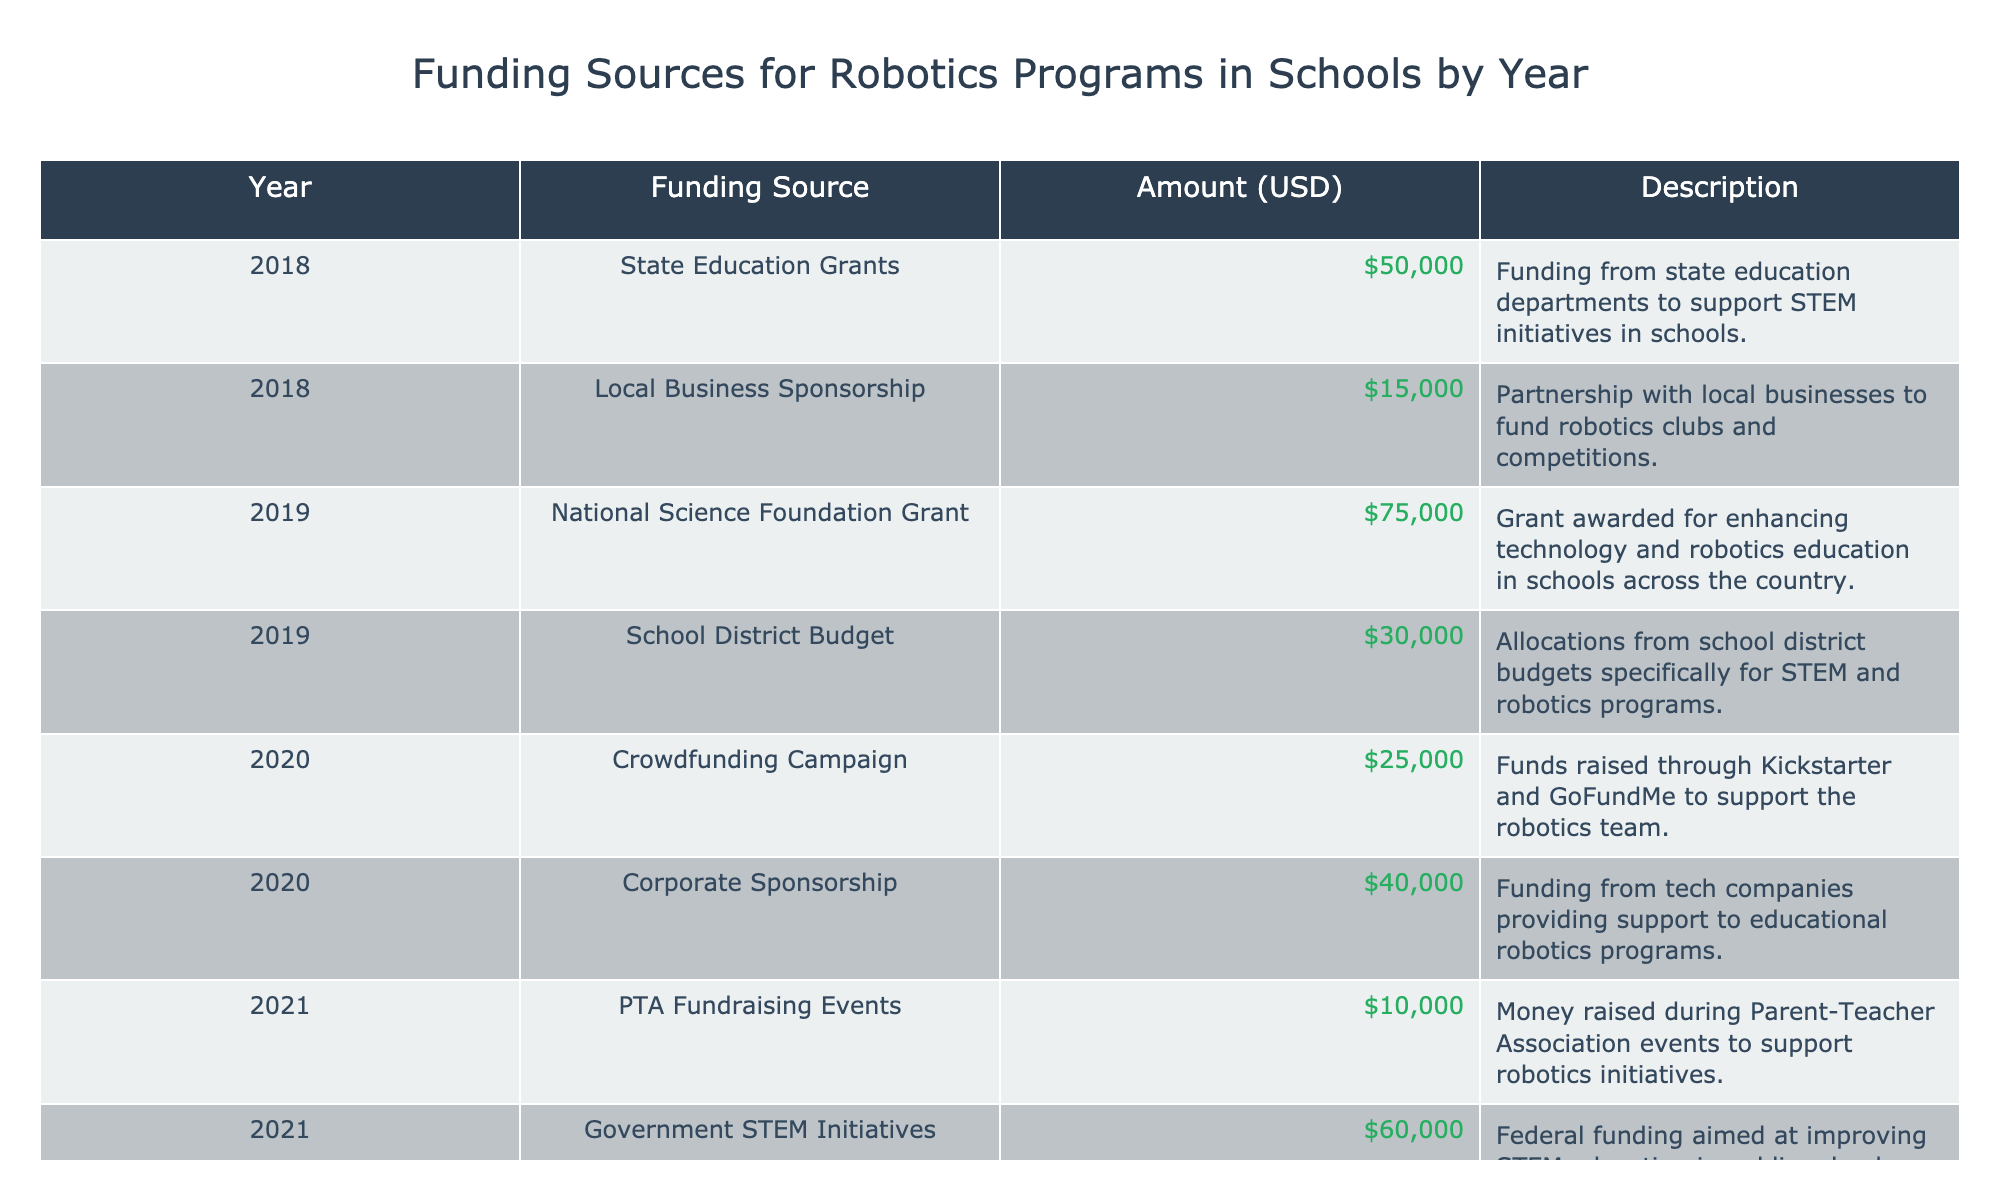What was the amount of funding from Local Business Sponsorship in 2018? Looking at the table, the amount listed for Local Business Sponsorship under the year 2018 is $15,000.
Answer: $15,000 What is the total amount of funding received from State Education Grants and Government STEM Initiatives combined? The amounts for State Education Grants and Government STEM Initiatives are $50,000 and $60,000, respectively. Adding these together gives $50,000 + $60,000 = $110,000.
Answer: $110,000 Did the funding from Corporate Sponsorship in 2020 exceed $30,000? The table shows that the Corporate Sponsorship amount for 2020 is $40,000, which is greater than $30,000. Thus, the statement is true.
Answer: Yes What year had the highest amount of funding from the Tech Industry Partnership? The table indicates that the Tech Industry Partnership provided funding in 2023 with an amount of $90,000, which is the highest amount listed for any funding source.
Answer: 2023 What was the average funding from Local Community Foundation and Robotics Competition Grants in 2022? The amounts for the Local Community Foundation and Robotics Competition Grants in 2022 are $12,000 and $20,000. To find the average, add these two amounts ($12,000 + $20,000 = $32,000) and divide by the number of entries (2). Thus, the average is $32,000 / 2 = $16,000.
Answer: $16,000 Was there an increase in funding from the School District Budget in 2019 compared to 2018? In the table, the School District Budget funding is shown only for 2019, which amounts to $30,000. There is no entry for 2018. Therefore, we cannot determine an increase based on the available data.
Answer: No How much total funding was provided for STEM initiatives from the PTA Fundraising Events and the Local Business Sponsorship in 2018? The PTA Fundraising Events in 2021 contributed $10,000, while the Local Business Sponsorship in 2018 contributed $15,000. The total funding is calculated as $10,000 + $15,000 = $25,000.
Answer: $25,000 Compare the total funding received in 2020 to that in 2021. Which year had more total funding? In 2020, the total funding was $25,000 (Crowdfunding Campaign) + $40,000 (Corporate Sponsorship) = $65,000. In 2021, the total funding was $10,000 (PTA Fundraising Events) + $60,000 (Government STEM Initiatives) = $70,000. Comparing these amounts, 2021 had more total funding.
Answer: 2021 